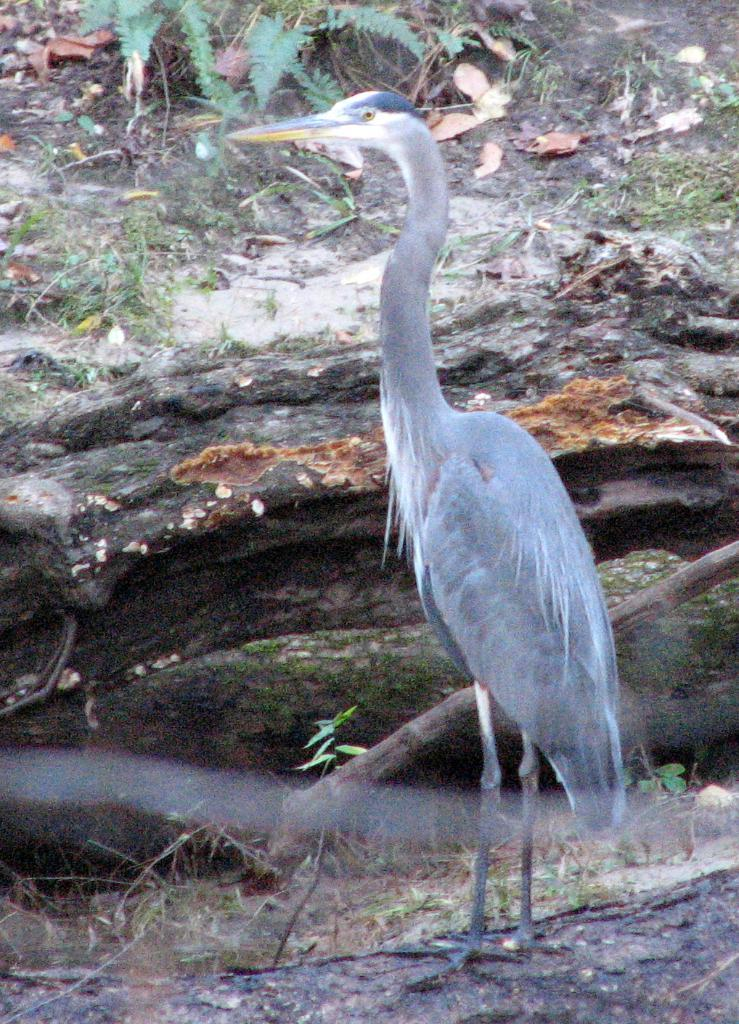Where was the picture taken? The picture was clicked outside. What can be seen in the foreground of the image? There is a bird standing on the ground in the foreground. What type of vegetation is visible in the image? Green leaves are visible in the image. What type of natural formation is present in the image? Rocks are present in the image. Can you describe any other items visible in the image? There are other items visible in the image, but their specific nature is not mentioned in the provided facts. What type of silk is being used to make the bird's nest in the image? There is no bird's nest visible in the image, and therefore no silk can be associated with it. 